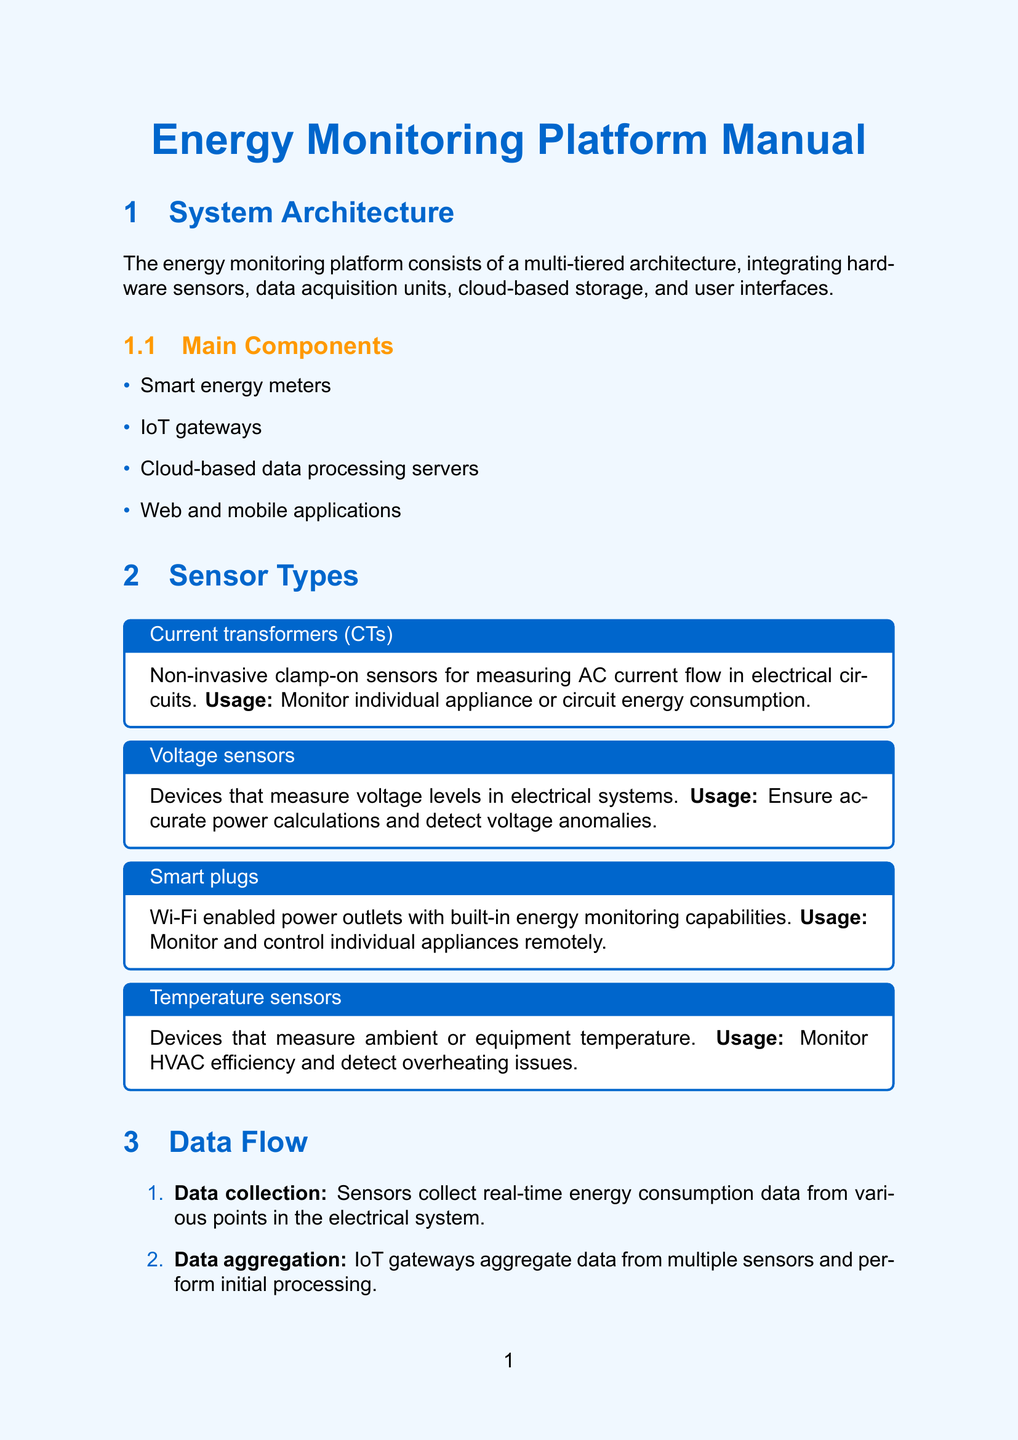what is the model of the smart meter? The model of the smart meter is mentioned in the hardware specifications section of the document.
Answer: EnergyTrack Pro X1 what type of sensors are used for measuring AC current flow? The document provides a specific type of sensor used for measuring AC current flow under the sensor types section.
Answer: Current transformers how many stages are in the data flow? This information can be found in the data flow section, listing out the distinct stages involved.
Answer: Six what is the accuracy of the smart meter? The accuracy of the smart meter is listed under its specifications.
Answer: ±0.5% how does the system handle user access? User access handling is detailed under the data security section, specifying the methods used for authentication.
Answer: Multi-factor authentication which software component is optimized for energy monitoring applications? A specific software component is described as optimized for energy monitoring applications under the software components section.
Answer: EnergyOS what is the maximum number of connected devices supported per regional cluster? This information is provided in the scalability section, indicating the system's capacity limits.
Answer: 1 million what is the communication method for the IoT gateway? The communication method used by the IoT gateway is specified in its hardware specifications section.
Answer: Ethernet, Wi-Fi, Cellular (4G/LTE) what compliance standards does the system adhere to? Compliance standards are listed in the data security section, indicating adherence to specific regulations.
Answer: GDPR and ISO 27001 